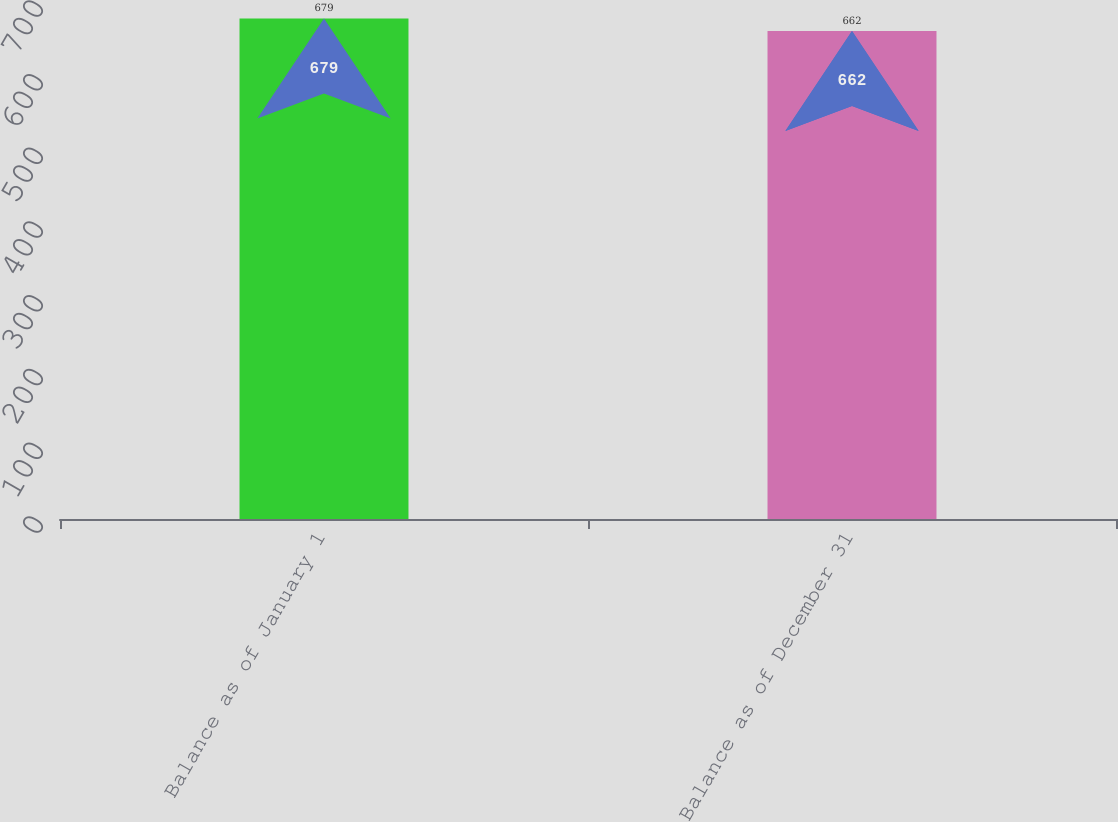Convert chart to OTSL. <chart><loc_0><loc_0><loc_500><loc_500><bar_chart><fcel>Balance as of January 1<fcel>Balance as of December 31<nl><fcel>679<fcel>662<nl></chart> 